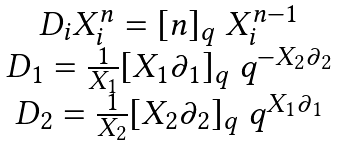<formula> <loc_0><loc_0><loc_500><loc_500>\begin{array} { c } D _ { i } X ^ { n } _ { i } = [ n ] _ { q } \ X ^ { n - 1 } _ { i } \\ D _ { 1 } = \frac { 1 } { X _ { 1 } } [ X _ { 1 } \partial _ { 1 } ] _ { q } \ q ^ { - X _ { 2 } \partial _ { 2 } } \\ D _ { 2 } = \frac { 1 } { X _ { 2 } } [ X _ { 2 } \partial _ { 2 } ] _ { q } \ q ^ { X _ { 1 } \partial _ { 1 } } \end{array}</formula> 